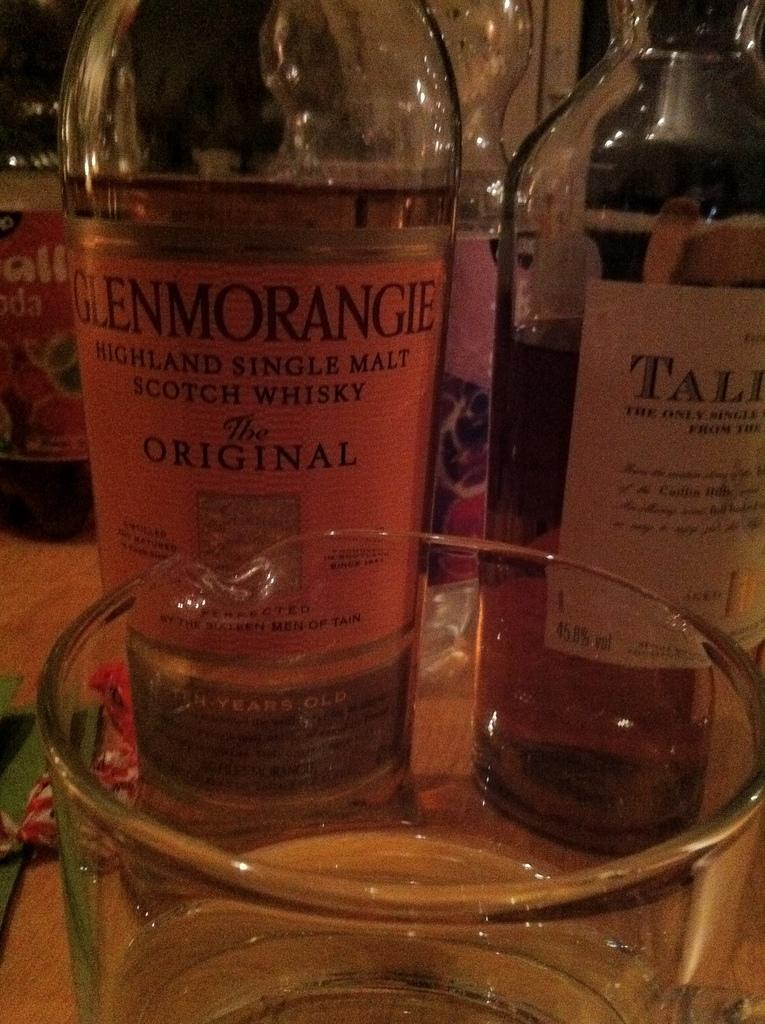What types of containers are visible in the image? There are bottles with different labels in the image. What other object can be seen in the image? There is a glass in the image. What type of underwear is visible in the image? There is no underwear present in the image. How does the sail appear in the image? There is no sail present in the image. 